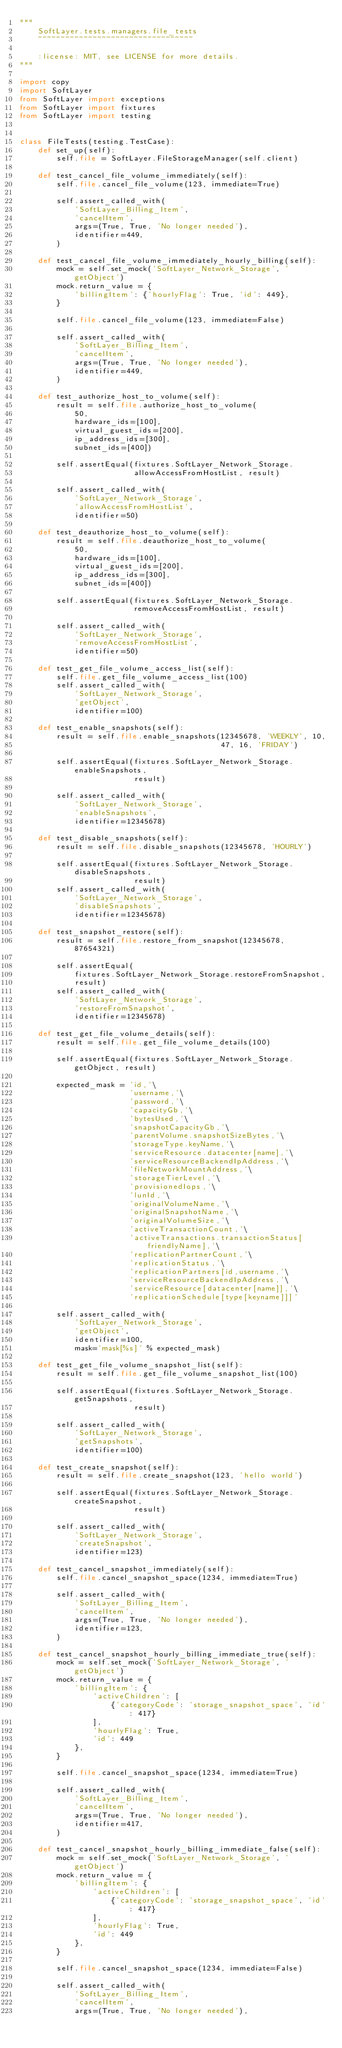Convert code to text. <code><loc_0><loc_0><loc_500><loc_500><_Python_>"""
    SoftLayer.tests.managers.file_tests
    ~~~~~~~~~~~~~~~~~~~~~~~~~~~~~~~~~~

    :license: MIT, see LICENSE for more details.
"""

import copy
import SoftLayer
from SoftLayer import exceptions
from SoftLayer import fixtures
from SoftLayer import testing


class FileTests(testing.TestCase):
    def set_up(self):
        self.file = SoftLayer.FileStorageManager(self.client)

    def test_cancel_file_volume_immediately(self):
        self.file.cancel_file_volume(123, immediate=True)

        self.assert_called_with(
            'SoftLayer_Billing_Item',
            'cancelItem',
            args=(True, True, 'No longer needed'),
            identifier=449,
        )

    def test_cancel_file_volume_immediately_hourly_billing(self):
        mock = self.set_mock('SoftLayer_Network_Storage', 'getObject')
        mock.return_value = {
            'billingItem': {'hourlyFlag': True, 'id': 449},
        }

        self.file.cancel_file_volume(123, immediate=False)

        self.assert_called_with(
            'SoftLayer_Billing_Item',
            'cancelItem',
            args=(True, True, 'No longer needed'),
            identifier=449,
        )

    def test_authorize_host_to_volume(self):
        result = self.file.authorize_host_to_volume(
            50,
            hardware_ids=[100],
            virtual_guest_ids=[200],
            ip_address_ids=[300],
            subnet_ids=[400])

        self.assertEqual(fixtures.SoftLayer_Network_Storage.
                         allowAccessFromHostList, result)

        self.assert_called_with(
            'SoftLayer_Network_Storage',
            'allowAccessFromHostList',
            identifier=50)

    def test_deauthorize_host_to_volume(self):
        result = self.file.deauthorize_host_to_volume(
            50,
            hardware_ids=[100],
            virtual_guest_ids=[200],
            ip_address_ids=[300],
            subnet_ids=[400])

        self.assertEqual(fixtures.SoftLayer_Network_Storage.
                         removeAccessFromHostList, result)

        self.assert_called_with(
            'SoftLayer_Network_Storage',
            'removeAccessFromHostList',
            identifier=50)

    def test_get_file_volume_access_list(self):
        self.file.get_file_volume_access_list(100)
        self.assert_called_with(
            'SoftLayer_Network_Storage',
            'getObject',
            identifier=100)

    def test_enable_snapshots(self):
        result = self.file.enable_snapshots(12345678, 'WEEKLY', 10,
                                            47, 16, 'FRIDAY')

        self.assertEqual(fixtures.SoftLayer_Network_Storage.enableSnapshots,
                         result)

        self.assert_called_with(
            'SoftLayer_Network_Storage',
            'enableSnapshots',
            identifier=12345678)

    def test_disable_snapshots(self):
        result = self.file.disable_snapshots(12345678, 'HOURLY')

        self.assertEqual(fixtures.SoftLayer_Network_Storage.disableSnapshots,
                         result)
        self.assert_called_with(
            'SoftLayer_Network_Storage',
            'disableSnapshots',
            identifier=12345678)

    def test_snapshot_restore(self):
        result = self.file.restore_from_snapshot(12345678, 87654321)

        self.assertEqual(
            fixtures.SoftLayer_Network_Storage.restoreFromSnapshot,
            result)
        self.assert_called_with(
            'SoftLayer_Network_Storage',
            'restoreFromSnapshot',
            identifier=12345678)

    def test_get_file_volume_details(self):
        result = self.file.get_file_volume_details(100)

        self.assertEqual(fixtures.SoftLayer_Network_Storage.getObject, result)

        expected_mask = 'id,'\
                        'username,'\
                        'password,'\
                        'capacityGb,'\
                        'bytesUsed,'\
                        'snapshotCapacityGb,'\
                        'parentVolume.snapshotSizeBytes,'\
                        'storageType.keyName,'\
                        'serviceResource.datacenter[name],'\
                        'serviceResourceBackendIpAddress,'\
                        'fileNetworkMountAddress,'\
                        'storageTierLevel,'\
                        'provisionedIops,'\
                        'lunId,'\
                        'originalVolumeName,'\
                        'originalSnapshotName,'\
                        'originalVolumeSize,'\
                        'activeTransactionCount,'\
                        'activeTransactions.transactionStatus[friendlyName],'\
                        'replicationPartnerCount,'\
                        'replicationStatus,'\
                        'replicationPartners[id,username,'\
                        'serviceResourceBackendIpAddress,'\
                        'serviceResource[datacenter[name]],'\
                        'replicationSchedule[type[keyname]]]'

        self.assert_called_with(
            'SoftLayer_Network_Storage',
            'getObject',
            identifier=100,
            mask='mask[%s]' % expected_mask)

    def test_get_file_volume_snapshot_list(self):
        result = self.file.get_file_volume_snapshot_list(100)

        self.assertEqual(fixtures.SoftLayer_Network_Storage.getSnapshots,
                         result)

        self.assert_called_with(
            'SoftLayer_Network_Storage',
            'getSnapshots',
            identifier=100)

    def test_create_snapshot(self):
        result = self.file.create_snapshot(123, 'hello world')

        self.assertEqual(fixtures.SoftLayer_Network_Storage.createSnapshot,
                         result)

        self.assert_called_with(
            'SoftLayer_Network_Storage',
            'createSnapshot',
            identifier=123)

    def test_cancel_snapshot_immediately(self):
        self.file.cancel_snapshot_space(1234, immediate=True)

        self.assert_called_with(
            'SoftLayer_Billing_Item',
            'cancelItem',
            args=(True, True, 'No longer needed'),
            identifier=123,
        )

    def test_cancel_snapshot_hourly_billing_immediate_true(self):
        mock = self.set_mock('SoftLayer_Network_Storage', 'getObject')
        mock.return_value = {
            'billingItem': {
                'activeChildren': [
                    {'categoryCode': 'storage_snapshot_space', 'id': 417}
                ],
                'hourlyFlag': True,
                'id': 449
            },
        }

        self.file.cancel_snapshot_space(1234, immediate=True)

        self.assert_called_with(
            'SoftLayer_Billing_Item',
            'cancelItem',
            args=(True, True, 'No longer needed'),
            identifier=417,
        )

    def test_cancel_snapshot_hourly_billing_immediate_false(self):
        mock = self.set_mock('SoftLayer_Network_Storage', 'getObject')
        mock.return_value = {
            'billingItem': {
                'activeChildren': [
                    {'categoryCode': 'storage_snapshot_space', 'id': 417}
                ],
                'hourlyFlag': True,
                'id': 449
            },
        }

        self.file.cancel_snapshot_space(1234, immediate=False)

        self.assert_called_with(
            'SoftLayer_Billing_Item',
            'cancelItem',
            args=(True, True, 'No longer needed'),</code> 